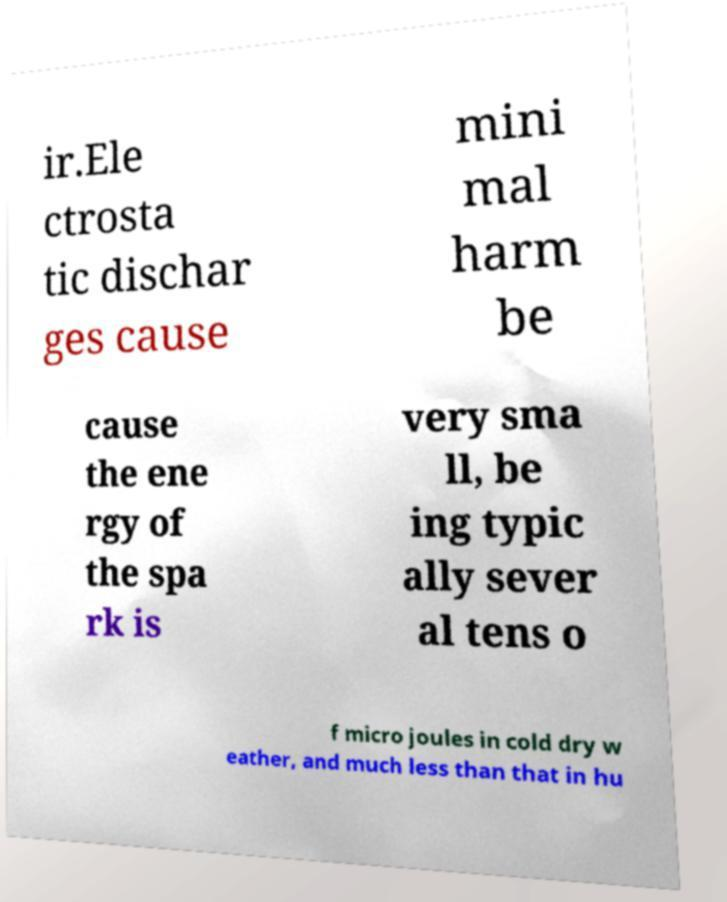Can you accurately transcribe the text from the provided image for me? ir.Ele ctrosta tic dischar ges cause mini mal harm be cause the ene rgy of the spa rk is very sma ll, be ing typic ally sever al tens o f micro joules in cold dry w eather, and much less than that in hu 